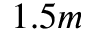<formula> <loc_0><loc_0><loc_500><loc_500>1 . 5 m</formula> 